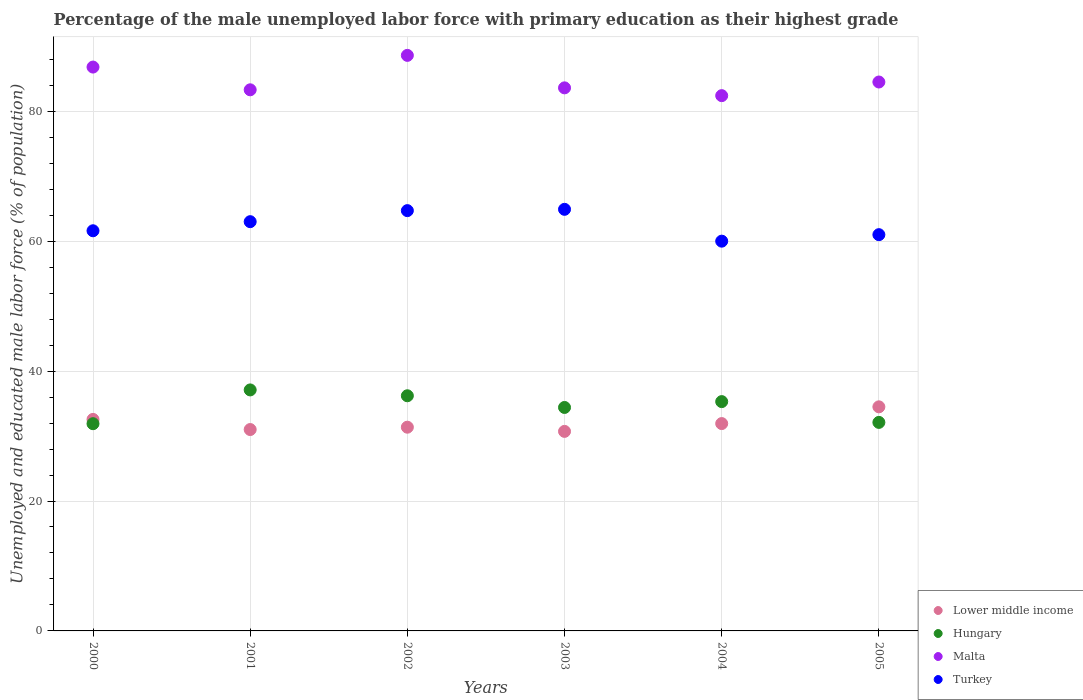What is the percentage of the unemployed male labor force with primary education in Turkey in 2003?
Your response must be concise. 64.9. Across all years, what is the maximum percentage of the unemployed male labor force with primary education in Turkey?
Provide a succinct answer. 64.9. Across all years, what is the minimum percentage of the unemployed male labor force with primary education in Lower middle income?
Keep it short and to the point. 30.72. In which year was the percentage of the unemployed male labor force with primary education in Turkey minimum?
Ensure brevity in your answer.  2004. What is the total percentage of the unemployed male labor force with primary education in Turkey in the graph?
Your answer should be compact. 375.2. What is the difference between the percentage of the unemployed male labor force with primary education in Lower middle income in 2000 and that in 2003?
Keep it short and to the point. 1.84. What is the difference between the percentage of the unemployed male labor force with primary education in Turkey in 2004 and the percentage of the unemployed male labor force with primary education in Malta in 2003?
Offer a very short reply. -23.6. What is the average percentage of the unemployed male labor force with primary education in Malta per year?
Your answer should be compact. 84.87. In the year 2002, what is the difference between the percentage of the unemployed male labor force with primary education in Lower middle income and percentage of the unemployed male labor force with primary education in Malta?
Your answer should be compact. -57.24. What is the ratio of the percentage of the unemployed male labor force with primary education in Turkey in 2000 to that in 2002?
Your answer should be very brief. 0.95. Is the percentage of the unemployed male labor force with primary education in Lower middle income in 2002 less than that in 2004?
Your response must be concise. Yes. Is the difference between the percentage of the unemployed male labor force with primary education in Lower middle income in 2000 and 2004 greater than the difference between the percentage of the unemployed male labor force with primary education in Malta in 2000 and 2004?
Keep it short and to the point. No. What is the difference between the highest and the second highest percentage of the unemployed male labor force with primary education in Turkey?
Give a very brief answer. 0.2. What is the difference between the highest and the lowest percentage of the unemployed male labor force with primary education in Malta?
Your answer should be compact. 6.2. In how many years, is the percentage of the unemployed male labor force with primary education in Turkey greater than the average percentage of the unemployed male labor force with primary education in Turkey taken over all years?
Keep it short and to the point. 3. Is the sum of the percentage of the unemployed male labor force with primary education in Turkey in 2002 and 2004 greater than the maximum percentage of the unemployed male labor force with primary education in Malta across all years?
Ensure brevity in your answer.  Yes. Does the percentage of the unemployed male labor force with primary education in Lower middle income monotonically increase over the years?
Offer a terse response. No. How many years are there in the graph?
Make the answer very short. 6. Are the values on the major ticks of Y-axis written in scientific E-notation?
Offer a very short reply. No. Does the graph contain any zero values?
Your response must be concise. No. Does the graph contain grids?
Your answer should be very brief. Yes. How many legend labels are there?
Ensure brevity in your answer.  4. How are the legend labels stacked?
Your response must be concise. Vertical. What is the title of the graph?
Ensure brevity in your answer.  Percentage of the male unemployed labor force with primary education as their highest grade. What is the label or title of the X-axis?
Your answer should be compact. Years. What is the label or title of the Y-axis?
Your response must be concise. Unemployed and educated male labor force (% of population). What is the Unemployed and educated male labor force (% of population) in Lower middle income in 2000?
Provide a succinct answer. 32.56. What is the Unemployed and educated male labor force (% of population) in Hungary in 2000?
Your answer should be compact. 31.9. What is the Unemployed and educated male labor force (% of population) in Malta in 2000?
Your answer should be compact. 86.8. What is the Unemployed and educated male labor force (% of population) of Turkey in 2000?
Offer a very short reply. 61.6. What is the Unemployed and educated male labor force (% of population) of Lower middle income in 2001?
Your answer should be very brief. 31. What is the Unemployed and educated male labor force (% of population) of Hungary in 2001?
Give a very brief answer. 37.1. What is the Unemployed and educated male labor force (% of population) of Malta in 2001?
Give a very brief answer. 83.3. What is the Unemployed and educated male labor force (% of population) in Turkey in 2001?
Give a very brief answer. 63. What is the Unemployed and educated male labor force (% of population) of Lower middle income in 2002?
Give a very brief answer. 31.36. What is the Unemployed and educated male labor force (% of population) of Hungary in 2002?
Make the answer very short. 36.2. What is the Unemployed and educated male labor force (% of population) of Malta in 2002?
Make the answer very short. 88.6. What is the Unemployed and educated male labor force (% of population) of Turkey in 2002?
Your answer should be very brief. 64.7. What is the Unemployed and educated male labor force (% of population) of Lower middle income in 2003?
Keep it short and to the point. 30.72. What is the Unemployed and educated male labor force (% of population) in Hungary in 2003?
Give a very brief answer. 34.4. What is the Unemployed and educated male labor force (% of population) of Malta in 2003?
Your answer should be compact. 83.6. What is the Unemployed and educated male labor force (% of population) of Turkey in 2003?
Provide a short and direct response. 64.9. What is the Unemployed and educated male labor force (% of population) of Lower middle income in 2004?
Provide a short and direct response. 31.92. What is the Unemployed and educated male labor force (% of population) of Hungary in 2004?
Provide a short and direct response. 35.3. What is the Unemployed and educated male labor force (% of population) of Malta in 2004?
Give a very brief answer. 82.4. What is the Unemployed and educated male labor force (% of population) in Turkey in 2004?
Your answer should be very brief. 60. What is the Unemployed and educated male labor force (% of population) of Lower middle income in 2005?
Offer a terse response. 34.5. What is the Unemployed and educated male labor force (% of population) in Hungary in 2005?
Give a very brief answer. 32.1. What is the Unemployed and educated male labor force (% of population) of Malta in 2005?
Provide a short and direct response. 84.5. Across all years, what is the maximum Unemployed and educated male labor force (% of population) in Lower middle income?
Keep it short and to the point. 34.5. Across all years, what is the maximum Unemployed and educated male labor force (% of population) in Hungary?
Make the answer very short. 37.1. Across all years, what is the maximum Unemployed and educated male labor force (% of population) in Malta?
Your response must be concise. 88.6. Across all years, what is the maximum Unemployed and educated male labor force (% of population) of Turkey?
Your answer should be compact. 64.9. Across all years, what is the minimum Unemployed and educated male labor force (% of population) of Lower middle income?
Your answer should be very brief. 30.72. Across all years, what is the minimum Unemployed and educated male labor force (% of population) in Hungary?
Provide a short and direct response. 31.9. Across all years, what is the minimum Unemployed and educated male labor force (% of population) of Malta?
Your answer should be very brief. 82.4. Across all years, what is the minimum Unemployed and educated male labor force (% of population) of Turkey?
Provide a short and direct response. 60. What is the total Unemployed and educated male labor force (% of population) of Lower middle income in the graph?
Your response must be concise. 192.05. What is the total Unemployed and educated male labor force (% of population) in Hungary in the graph?
Your answer should be very brief. 207. What is the total Unemployed and educated male labor force (% of population) of Malta in the graph?
Your answer should be compact. 509.2. What is the total Unemployed and educated male labor force (% of population) in Turkey in the graph?
Offer a very short reply. 375.2. What is the difference between the Unemployed and educated male labor force (% of population) in Lower middle income in 2000 and that in 2001?
Provide a succinct answer. 1.56. What is the difference between the Unemployed and educated male labor force (% of population) of Malta in 2000 and that in 2001?
Keep it short and to the point. 3.5. What is the difference between the Unemployed and educated male labor force (% of population) in Turkey in 2000 and that in 2001?
Keep it short and to the point. -1.4. What is the difference between the Unemployed and educated male labor force (% of population) in Lower middle income in 2000 and that in 2002?
Your response must be concise. 1.2. What is the difference between the Unemployed and educated male labor force (% of population) of Malta in 2000 and that in 2002?
Provide a succinct answer. -1.8. What is the difference between the Unemployed and educated male labor force (% of population) of Lower middle income in 2000 and that in 2003?
Give a very brief answer. 1.84. What is the difference between the Unemployed and educated male labor force (% of population) in Turkey in 2000 and that in 2003?
Offer a very short reply. -3.3. What is the difference between the Unemployed and educated male labor force (% of population) in Lower middle income in 2000 and that in 2004?
Keep it short and to the point. 0.64. What is the difference between the Unemployed and educated male labor force (% of population) in Hungary in 2000 and that in 2004?
Offer a terse response. -3.4. What is the difference between the Unemployed and educated male labor force (% of population) in Lower middle income in 2000 and that in 2005?
Offer a very short reply. -1.94. What is the difference between the Unemployed and educated male labor force (% of population) in Malta in 2000 and that in 2005?
Provide a short and direct response. 2.3. What is the difference between the Unemployed and educated male labor force (% of population) of Lower middle income in 2001 and that in 2002?
Your answer should be very brief. -0.36. What is the difference between the Unemployed and educated male labor force (% of population) of Malta in 2001 and that in 2002?
Keep it short and to the point. -5.3. What is the difference between the Unemployed and educated male labor force (% of population) of Lower middle income in 2001 and that in 2003?
Provide a short and direct response. 0.28. What is the difference between the Unemployed and educated male labor force (% of population) of Lower middle income in 2001 and that in 2004?
Ensure brevity in your answer.  -0.92. What is the difference between the Unemployed and educated male labor force (% of population) of Hungary in 2001 and that in 2004?
Your answer should be very brief. 1.8. What is the difference between the Unemployed and educated male labor force (% of population) of Malta in 2001 and that in 2004?
Keep it short and to the point. 0.9. What is the difference between the Unemployed and educated male labor force (% of population) of Lower middle income in 2001 and that in 2005?
Provide a succinct answer. -3.49. What is the difference between the Unemployed and educated male labor force (% of population) of Hungary in 2001 and that in 2005?
Provide a succinct answer. 5. What is the difference between the Unemployed and educated male labor force (% of population) of Lower middle income in 2002 and that in 2003?
Give a very brief answer. 0.65. What is the difference between the Unemployed and educated male labor force (% of population) of Lower middle income in 2002 and that in 2004?
Make the answer very short. -0.56. What is the difference between the Unemployed and educated male labor force (% of population) of Malta in 2002 and that in 2004?
Offer a terse response. 6.2. What is the difference between the Unemployed and educated male labor force (% of population) in Lower middle income in 2002 and that in 2005?
Your response must be concise. -3.13. What is the difference between the Unemployed and educated male labor force (% of population) of Malta in 2002 and that in 2005?
Your answer should be very brief. 4.1. What is the difference between the Unemployed and educated male labor force (% of population) of Turkey in 2002 and that in 2005?
Provide a short and direct response. 3.7. What is the difference between the Unemployed and educated male labor force (% of population) of Lower middle income in 2003 and that in 2004?
Your answer should be compact. -1.2. What is the difference between the Unemployed and educated male labor force (% of population) of Hungary in 2003 and that in 2004?
Your answer should be compact. -0.9. What is the difference between the Unemployed and educated male labor force (% of population) of Turkey in 2003 and that in 2004?
Offer a terse response. 4.9. What is the difference between the Unemployed and educated male labor force (% of population) in Lower middle income in 2003 and that in 2005?
Ensure brevity in your answer.  -3.78. What is the difference between the Unemployed and educated male labor force (% of population) in Turkey in 2003 and that in 2005?
Make the answer very short. 3.9. What is the difference between the Unemployed and educated male labor force (% of population) of Lower middle income in 2004 and that in 2005?
Provide a succinct answer. -2.58. What is the difference between the Unemployed and educated male labor force (% of population) of Malta in 2004 and that in 2005?
Give a very brief answer. -2.1. What is the difference between the Unemployed and educated male labor force (% of population) of Lower middle income in 2000 and the Unemployed and educated male labor force (% of population) of Hungary in 2001?
Keep it short and to the point. -4.54. What is the difference between the Unemployed and educated male labor force (% of population) in Lower middle income in 2000 and the Unemployed and educated male labor force (% of population) in Malta in 2001?
Give a very brief answer. -50.74. What is the difference between the Unemployed and educated male labor force (% of population) in Lower middle income in 2000 and the Unemployed and educated male labor force (% of population) in Turkey in 2001?
Make the answer very short. -30.44. What is the difference between the Unemployed and educated male labor force (% of population) in Hungary in 2000 and the Unemployed and educated male labor force (% of population) in Malta in 2001?
Your answer should be compact. -51.4. What is the difference between the Unemployed and educated male labor force (% of population) in Hungary in 2000 and the Unemployed and educated male labor force (% of population) in Turkey in 2001?
Your answer should be compact. -31.1. What is the difference between the Unemployed and educated male labor force (% of population) in Malta in 2000 and the Unemployed and educated male labor force (% of population) in Turkey in 2001?
Your answer should be very brief. 23.8. What is the difference between the Unemployed and educated male labor force (% of population) in Lower middle income in 2000 and the Unemployed and educated male labor force (% of population) in Hungary in 2002?
Give a very brief answer. -3.64. What is the difference between the Unemployed and educated male labor force (% of population) in Lower middle income in 2000 and the Unemployed and educated male labor force (% of population) in Malta in 2002?
Ensure brevity in your answer.  -56.04. What is the difference between the Unemployed and educated male labor force (% of population) in Lower middle income in 2000 and the Unemployed and educated male labor force (% of population) in Turkey in 2002?
Give a very brief answer. -32.14. What is the difference between the Unemployed and educated male labor force (% of population) of Hungary in 2000 and the Unemployed and educated male labor force (% of population) of Malta in 2002?
Keep it short and to the point. -56.7. What is the difference between the Unemployed and educated male labor force (% of population) in Hungary in 2000 and the Unemployed and educated male labor force (% of population) in Turkey in 2002?
Provide a short and direct response. -32.8. What is the difference between the Unemployed and educated male labor force (% of population) of Malta in 2000 and the Unemployed and educated male labor force (% of population) of Turkey in 2002?
Offer a very short reply. 22.1. What is the difference between the Unemployed and educated male labor force (% of population) of Lower middle income in 2000 and the Unemployed and educated male labor force (% of population) of Hungary in 2003?
Ensure brevity in your answer.  -1.84. What is the difference between the Unemployed and educated male labor force (% of population) in Lower middle income in 2000 and the Unemployed and educated male labor force (% of population) in Malta in 2003?
Your answer should be very brief. -51.04. What is the difference between the Unemployed and educated male labor force (% of population) of Lower middle income in 2000 and the Unemployed and educated male labor force (% of population) of Turkey in 2003?
Ensure brevity in your answer.  -32.34. What is the difference between the Unemployed and educated male labor force (% of population) of Hungary in 2000 and the Unemployed and educated male labor force (% of population) of Malta in 2003?
Keep it short and to the point. -51.7. What is the difference between the Unemployed and educated male labor force (% of population) of Hungary in 2000 and the Unemployed and educated male labor force (% of population) of Turkey in 2003?
Offer a very short reply. -33. What is the difference between the Unemployed and educated male labor force (% of population) in Malta in 2000 and the Unemployed and educated male labor force (% of population) in Turkey in 2003?
Provide a succinct answer. 21.9. What is the difference between the Unemployed and educated male labor force (% of population) of Lower middle income in 2000 and the Unemployed and educated male labor force (% of population) of Hungary in 2004?
Ensure brevity in your answer.  -2.74. What is the difference between the Unemployed and educated male labor force (% of population) of Lower middle income in 2000 and the Unemployed and educated male labor force (% of population) of Malta in 2004?
Provide a short and direct response. -49.84. What is the difference between the Unemployed and educated male labor force (% of population) in Lower middle income in 2000 and the Unemployed and educated male labor force (% of population) in Turkey in 2004?
Keep it short and to the point. -27.44. What is the difference between the Unemployed and educated male labor force (% of population) of Hungary in 2000 and the Unemployed and educated male labor force (% of population) of Malta in 2004?
Offer a terse response. -50.5. What is the difference between the Unemployed and educated male labor force (% of population) in Hungary in 2000 and the Unemployed and educated male labor force (% of population) in Turkey in 2004?
Your answer should be compact. -28.1. What is the difference between the Unemployed and educated male labor force (% of population) in Malta in 2000 and the Unemployed and educated male labor force (% of population) in Turkey in 2004?
Offer a terse response. 26.8. What is the difference between the Unemployed and educated male labor force (% of population) of Lower middle income in 2000 and the Unemployed and educated male labor force (% of population) of Hungary in 2005?
Your response must be concise. 0.46. What is the difference between the Unemployed and educated male labor force (% of population) in Lower middle income in 2000 and the Unemployed and educated male labor force (% of population) in Malta in 2005?
Make the answer very short. -51.94. What is the difference between the Unemployed and educated male labor force (% of population) in Lower middle income in 2000 and the Unemployed and educated male labor force (% of population) in Turkey in 2005?
Your response must be concise. -28.44. What is the difference between the Unemployed and educated male labor force (% of population) in Hungary in 2000 and the Unemployed and educated male labor force (% of population) in Malta in 2005?
Provide a succinct answer. -52.6. What is the difference between the Unemployed and educated male labor force (% of population) in Hungary in 2000 and the Unemployed and educated male labor force (% of population) in Turkey in 2005?
Give a very brief answer. -29.1. What is the difference between the Unemployed and educated male labor force (% of population) in Malta in 2000 and the Unemployed and educated male labor force (% of population) in Turkey in 2005?
Offer a very short reply. 25.8. What is the difference between the Unemployed and educated male labor force (% of population) in Lower middle income in 2001 and the Unemployed and educated male labor force (% of population) in Hungary in 2002?
Your answer should be compact. -5.2. What is the difference between the Unemployed and educated male labor force (% of population) of Lower middle income in 2001 and the Unemployed and educated male labor force (% of population) of Malta in 2002?
Keep it short and to the point. -57.6. What is the difference between the Unemployed and educated male labor force (% of population) of Lower middle income in 2001 and the Unemployed and educated male labor force (% of population) of Turkey in 2002?
Offer a very short reply. -33.7. What is the difference between the Unemployed and educated male labor force (% of population) of Hungary in 2001 and the Unemployed and educated male labor force (% of population) of Malta in 2002?
Offer a terse response. -51.5. What is the difference between the Unemployed and educated male labor force (% of population) of Hungary in 2001 and the Unemployed and educated male labor force (% of population) of Turkey in 2002?
Your answer should be compact. -27.6. What is the difference between the Unemployed and educated male labor force (% of population) in Lower middle income in 2001 and the Unemployed and educated male labor force (% of population) in Hungary in 2003?
Make the answer very short. -3.4. What is the difference between the Unemployed and educated male labor force (% of population) of Lower middle income in 2001 and the Unemployed and educated male labor force (% of population) of Malta in 2003?
Give a very brief answer. -52.6. What is the difference between the Unemployed and educated male labor force (% of population) of Lower middle income in 2001 and the Unemployed and educated male labor force (% of population) of Turkey in 2003?
Keep it short and to the point. -33.9. What is the difference between the Unemployed and educated male labor force (% of population) in Hungary in 2001 and the Unemployed and educated male labor force (% of population) in Malta in 2003?
Provide a short and direct response. -46.5. What is the difference between the Unemployed and educated male labor force (% of population) of Hungary in 2001 and the Unemployed and educated male labor force (% of population) of Turkey in 2003?
Your answer should be very brief. -27.8. What is the difference between the Unemployed and educated male labor force (% of population) in Lower middle income in 2001 and the Unemployed and educated male labor force (% of population) in Hungary in 2004?
Make the answer very short. -4.3. What is the difference between the Unemployed and educated male labor force (% of population) in Lower middle income in 2001 and the Unemployed and educated male labor force (% of population) in Malta in 2004?
Make the answer very short. -51.4. What is the difference between the Unemployed and educated male labor force (% of population) in Lower middle income in 2001 and the Unemployed and educated male labor force (% of population) in Turkey in 2004?
Offer a terse response. -29. What is the difference between the Unemployed and educated male labor force (% of population) of Hungary in 2001 and the Unemployed and educated male labor force (% of population) of Malta in 2004?
Provide a succinct answer. -45.3. What is the difference between the Unemployed and educated male labor force (% of population) in Hungary in 2001 and the Unemployed and educated male labor force (% of population) in Turkey in 2004?
Your answer should be compact. -22.9. What is the difference between the Unemployed and educated male labor force (% of population) of Malta in 2001 and the Unemployed and educated male labor force (% of population) of Turkey in 2004?
Give a very brief answer. 23.3. What is the difference between the Unemployed and educated male labor force (% of population) in Lower middle income in 2001 and the Unemployed and educated male labor force (% of population) in Hungary in 2005?
Your answer should be very brief. -1.1. What is the difference between the Unemployed and educated male labor force (% of population) of Lower middle income in 2001 and the Unemployed and educated male labor force (% of population) of Malta in 2005?
Provide a short and direct response. -53.5. What is the difference between the Unemployed and educated male labor force (% of population) in Lower middle income in 2001 and the Unemployed and educated male labor force (% of population) in Turkey in 2005?
Make the answer very short. -30. What is the difference between the Unemployed and educated male labor force (% of population) in Hungary in 2001 and the Unemployed and educated male labor force (% of population) in Malta in 2005?
Your answer should be compact. -47.4. What is the difference between the Unemployed and educated male labor force (% of population) of Hungary in 2001 and the Unemployed and educated male labor force (% of population) of Turkey in 2005?
Offer a very short reply. -23.9. What is the difference between the Unemployed and educated male labor force (% of population) in Malta in 2001 and the Unemployed and educated male labor force (% of population) in Turkey in 2005?
Provide a short and direct response. 22.3. What is the difference between the Unemployed and educated male labor force (% of population) of Lower middle income in 2002 and the Unemployed and educated male labor force (% of population) of Hungary in 2003?
Provide a succinct answer. -3.04. What is the difference between the Unemployed and educated male labor force (% of population) in Lower middle income in 2002 and the Unemployed and educated male labor force (% of population) in Malta in 2003?
Make the answer very short. -52.24. What is the difference between the Unemployed and educated male labor force (% of population) in Lower middle income in 2002 and the Unemployed and educated male labor force (% of population) in Turkey in 2003?
Offer a terse response. -33.54. What is the difference between the Unemployed and educated male labor force (% of population) of Hungary in 2002 and the Unemployed and educated male labor force (% of population) of Malta in 2003?
Your response must be concise. -47.4. What is the difference between the Unemployed and educated male labor force (% of population) in Hungary in 2002 and the Unemployed and educated male labor force (% of population) in Turkey in 2003?
Provide a succinct answer. -28.7. What is the difference between the Unemployed and educated male labor force (% of population) of Malta in 2002 and the Unemployed and educated male labor force (% of population) of Turkey in 2003?
Give a very brief answer. 23.7. What is the difference between the Unemployed and educated male labor force (% of population) of Lower middle income in 2002 and the Unemployed and educated male labor force (% of population) of Hungary in 2004?
Provide a succinct answer. -3.94. What is the difference between the Unemployed and educated male labor force (% of population) of Lower middle income in 2002 and the Unemployed and educated male labor force (% of population) of Malta in 2004?
Keep it short and to the point. -51.04. What is the difference between the Unemployed and educated male labor force (% of population) of Lower middle income in 2002 and the Unemployed and educated male labor force (% of population) of Turkey in 2004?
Make the answer very short. -28.64. What is the difference between the Unemployed and educated male labor force (% of population) in Hungary in 2002 and the Unemployed and educated male labor force (% of population) in Malta in 2004?
Offer a terse response. -46.2. What is the difference between the Unemployed and educated male labor force (% of population) of Hungary in 2002 and the Unemployed and educated male labor force (% of population) of Turkey in 2004?
Your answer should be compact. -23.8. What is the difference between the Unemployed and educated male labor force (% of population) of Malta in 2002 and the Unemployed and educated male labor force (% of population) of Turkey in 2004?
Provide a short and direct response. 28.6. What is the difference between the Unemployed and educated male labor force (% of population) in Lower middle income in 2002 and the Unemployed and educated male labor force (% of population) in Hungary in 2005?
Keep it short and to the point. -0.74. What is the difference between the Unemployed and educated male labor force (% of population) in Lower middle income in 2002 and the Unemployed and educated male labor force (% of population) in Malta in 2005?
Give a very brief answer. -53.14. What is the difference between the Unemployed and educated male labor force (% of population) of Lower middle income in 2002 and the Unemployed and educated male labor force (% of population) of Turkey in 2005?
Your response must be concise. -29.64. What is the difference between the Unemployed and educated male labor force (% of population) in Hungary in 2002 and the Unemployed and educated male labor force (% of population) in Malta in 2005?
Your response must be concise. -48.3. What is the difference between the Unemployed and educated male labor force (% of population) in Hungary in 2002 and the Unemployed and educated male labor force (% of population) in Turkey in 2005?
Offer a very short reply. -24.8. What is the difference between the Unemployed and educated male labor force (% of population) of Malta in 2002 and the Unemployed and educated male labor force (% of population) of Turkey in 2005?
Provide a succinct answer. 27.6. What is the difference between the Unemployed and educated male labor force (% of population) in Lower middle income in 2003 and the Unemployed and educated male labor force (% of population) in Hungary in 2004?
Offer a terse response. -4.58. What is the difference between the Unemployed and educated male labor force (% of population) of Lower middle income in 2003 and the Unemployed and educated male labor force (% of population) of Malta in 2004?
Your answer should be very brief. -51.68. What is the difference between the Unemployed and educated male labor force (% of population) of Lower middle income in 2003 and the Unemployed and educated male labor force (% of population) of Turkey in 2004?
Offer a terse response. -29.28. What is the difference between the Unemployed and educated male labor force (% of population) of Hungary in 2003 and the Unemployed and educated male labor force (% of population) of Malta in 2004?
Offer a very short reply. -48. What is the difference between the Unemployed and educated male labor force (% of population) in Hungary in 2003 and the Unemployed and educated male labor force (% of population) in Turkey in 2004?
Make the answer very short. -25.6. What is the difference between the Unemployed and educated male labor force (% of population) of Malta in 2003 and the Unemployed and educated male labor force (% of population) of Turkey in 2004?
Your answer should be very brief. 23.6. What is the difference between the Unemployed and educated male labor force (% of population) in Lower middle income in 2003 and the Unemployed and educated male labor force (% of population) in Hungary in 2005?
Your answer should be very brief. -1.38. What is the difference between the Unemployed and educated male labor force (% of population) of Lower middle income in 2003 and the Unemployed and educated male labor force (% of population) of Malta in 2005?
Offer a terse response. -53.78. What is the difference between the Unemployed and educated male labor force (% of population) of Lower middle income in 2003 and the Unemployed and educated male labor force (% of population) of Turkey in 2005?
Provide a succinct answer. -30.28. What is the difference between the Unemployed and educated male labor force (% of population) in Hungary in 2003 and the Unemployed and educated male labor force (% of population) in Malta in 2005?
Offer a terse response. -50.1. What is the difference between the Unemployed and educated male labor force (% of population) of Hungary in 2003 and the Unemployed and educated male labor force (% of population) of Turkey in 2005?
Provide a succinct answer. -26.6. What is the difference between the Unemployed and educated male labor force (% of population) of Malta in 2003 and the Unemployed and educated male labor force (% of population) of Turkey in 2005?
Your response must be concise. 22.6. What is the difference between the Unemployed and educated male labor force (% of population) of Lower middle income in 2004 and the Unemployed and educated male labor force (% of population) of Hungary in 2005?
Make the answer very short. -0.18. What is the difference between the Unemployed and educated male labor force (% of population) of Lower middle income in 2004 and the Unemployed and educated male labor force (% of population) of Malta in 2005?
Make the answer very short. -52.58. What is the difference between the Unemployed and educated male labor force (% of population) in Lower middle income in 2004 and the Unemployed and educated male labor force (% of population) in Turkey in 2005?
Your response must be concise. -29.08. What is the difference between the Unemployed and educated male labor force (% of population) in Hungary in 2004 and the Unemployed and educated male labor force (% of population) in Malta in 2005?
Give a very brief answer. -49.2. What is the difference between the Unemployed and educated male labor force (% of population) in Hungary in 2004 and the Unemployed and educated male labor force (% of population) in Turkey in 2005?
Keep it short and to the point. -25.7. What is the difference between the Unemployed and educated male labor force (% of population) of Malta in 2004 and the Unemployed and educated male labor force (% of population) of Turkey in 2005?
Provide a succinct answer. 21.4. What is the average Unemployed and educated male labor force (% of population) in Lower middle income per year?
Give a very brief answer. 32.01. What is the average Unemployed and educated male labor force (% of population) in Hungary per year?
Your response must be concise. 34.5. What is the average Unemployed and educated male labor force (% of population) of Malta per year?
Keep it short and to the point. 84.87. What is the average Unemployed and educated male labor force (% of population) in Turkey per year?
Make the answer very short. 62.53. In the year 2000, what is the difference between the Unemployed and educated male labor force (% of population) of Lower middle income and Unemployed and educated male labor force (% of population) of Hungary?
Your response must be concise. 0.66. In the year 2000, what is the difference between the Unemployed and educated male labor force (% of population) of Lower middle income and Unemployed and educated male labor force (% of population) of Malta?
Your response must be concise. -54.24. In the year 2000, what is the difference between the Unemployed and educated male labor force (% of population) of Lower middle income and Unemployed and educated male labor force (% of population) of Turkey?
Give a very brief answer. -29.04. In the year 2000, what is the difference between the Unemployed and educated male labor force (% of population) in Hungary and Unemployed and educated male labor force (% of population) in Malta?
Your response must be concise. -54.9. In the year 2000, what is the difference between the Unemployed and educated male labor force (% of population) of Hungary and Unemployed and educated male labor force (% of population) of Turkey?
Offer a terse response. -29.7. In the year 2000, what is the difference between the Unemployed and educated male labor force (% of population) in Malta and Unemployed and educated male labor force (% of population) in Turkey?
Keep it short and to the point. 25.2. In the year 2001, what is the difference between the Unemployed and educated male labor force (% of population) of Lower middle income and Unemployed and educated male labor force (% of population) of Hungary?
Keep it short and to the point. -6.1. In the year 2001, what is the difference between the Unemployed and educated male labor force (% of population) in Lower middle income and Unemployed and educated male labor force (% of population) in Malta?
Ensure brevity in your answer.  -52.3. In the year 2001, what is the difference between the Unemployed and educated male labor force (% of population) of Lower middle income and Unemployed and educated male labor force (% of population) of Turkey?
Your answer should be compact. -32. In the year 2001, what is the difference between the Unemployed and educated male labor force (% of population) in Hungary and Unemployed and educated male labor force (% of population) in Malta?
Your answer should be compact. -46.2. In the year 2001, what is the difference between the Unemployed and educated male labor force (% of population) in Hungary and Unemployed and educated male labor force (% of population) in Turkey?
Provide a succinct answer. -25.9. In the year 2001, what is the difference between the Unemployed and educated male labor force (% of population) in Malta and Unemployed and educated male labor force (% of population) in Turkey?
Offer a terse response. 20.3. In the year 2002, what is the difference between the Unemployed and educated male labor force (% of population) of Lower middle income and Unemployed and educated male labor force (% of population) of Hungary?
Make the answer very short. -4.84. In the year 2002, what is the difference between the Unemployed and educated male labor force (% of population) in Lower middle income and Unemployed and educated male labor force (% of population) in Malta?
Your answer should be compact. -57.24. In the year 2002, what is the difference between the Unemployed and educated male labor force (% of population) in Lower middle income and Unemployed and educated male labor force (% of population) in Turkey?
Offer a very short reply. -33.34. In the year 2002, what is the difference between the Unemployed and educated male labor force (% of population) in Hungary and Unemployed and educated male labor force (% of population) in Malta?
Give a very brief answer. -52.4. In the year 2002, what is the difference between the Unemployed and educated male labor force (% of population) of Hungary and Unemployed and educated male labor force (% of population) of Turkey?
Make the answer very short. -28.5. In the year 2002, what is the difference between the Unemployed and educated male labor force (% of population) of Malta and Unemployed and educated male labor force (% of population) of Turkey?
Provide a succinct answer. 23.9. In the year 2003, what is the difference between the Unemployed and educated male labor force (% of population) in Lower middle income and Unemployed and educated male labor force (% of population) in Hungary?
Give a very brief answer. -3.68. In the year 2003, what is the difference between the Unemployed and educated male labor force (% of population) of Lower middle income and Unemployed and educated male labor force (% of population) of Malta?
Make the answer very short. -52.88. In the year 2003, what is the difference between the Unemployed and educated male labor force (% of population) of Lower middle income and Unemployed and educated male labor force (% of population) of Turkey?
Ensure brevity in your answer.  -34.18. In the year 2003, what is the difference between the Unemployed and educated male labor force (% of population) of Hungary and Unemployed and educated male labor force (% of population) of Malta?
Ensure brevity in your answer.  -49.2. In the year 2003, what is the difference between the Unemployed and educated male labor force (% of population) in Hungary and Unemployed and educated male labor force (% of population) in Turkey?
Keep it short and to the point. -30.5. In the year 2004, what is the difference between the Unemployed and educated male labor force (% of population) in Lower middle income and Unemployed and educated male labor force (% of population) in Hungary?
Your answer should be compact. -3.38. In the year 2004, what is the difference between the Unemployed and educated male labor force (% of population) in Lower middle income and Unemployed and educated male labor force (% of population) in Malta?
Provide a short and direct response. -50.48. In the year 2004, what is the difference between the Unemployed and educated male labor force (% of population) in Lower middle income and Unemployed and educated male labor force (% of population) in Turkey?
Make the answer very short. -28.08. In the year 2004, what is the difference between the Unemployed and educated male labor force (% of population) in Hungary and Unemployed and educated male labor force (% of population) in Malta?
Provide a short and direct response. -47.1. In the year 2004, what is the difference between the Unemployed and educated male labor force (% of population) in Hungary and Unemployed and educated male labor force (% of population) in Turkey?
Offer a very short reply. -24.7. In the year 2004, what is the difference between the Unemployed and educated male labor force (% of population) in Malta and Unemployed and educated male labor force (% of population) in Turkey?
Make the answer very short. 22.4. In the year 2005, what is the difference between the Unemployed and educated male labor force (% of population) in Lower middle income and Unemployed and educated male labor force (% of population) in Hungary?
Give a very brief answer. 2.4. In the year 2005, what is the difference between the Unemployed and educated male labor force (% of population) of Lower middle income and Unemployed and educated male labor force (% of population) of Malta?
Your response must be concise. -50. In the year 2005, what is the difference between the Unemployed and educated male labor force (% of population) in Lower middle income and Unemployed and educated male labor force (% of population) in Turkey?
Your response must be concise. -26.5. In the year 2005, what is the difference between the Unemployed and educated male labor force (% of population) of Hungary and Unemployed and educated male labor force (% of population) of Malta?
Your response must be concise. -52.4. In the year 2005, what is the difference between the Unemployed and educated male labor force (% of population) in Hungary and Unemployed and educated male labor force (% of population) in Turkey?
Keep it short and to the point. -28.9. What is the ratio of the Unemployed and educated male labor force (% of population) in Lower middle income in 2000 to that in 2001?
Make the answer very short. 1.05. What is the ratio of the Unemployed and educated male labor force (% of population) of Hungary in 2000 to that in 2001?
Provide a succinct answer. 0.86. What is the ratio of the Unemployed and educated male labor force (% of population) of Malta in 2000 to that in 2001?
Provide a short and direct response. 1.04. What is the ratio of the Unemployed and educated male labor force (% of population) of Turkey in 2000 to that in 2001?
Keep it short and to the point. 0.98. What is the ratio of the Unemployed and educated male labor force (% of population) of Lower middle income in 2000 to that in 2002?
Give a very brief answer. 1.04. What is the ratio of the Unemployed and educated male labor force (% of population) in Hungary in 2000 to that in 2002?
Ensure brevity in your answer.  0.88. What is the ratio of the Unemployed and educated male labor force (% of population) in Malta in 2000 to that in 2002?
Offer a very short reply. 0.98. What is the ratio of the Unemployed and educated male labor force (% of population) in Turkey in 2000 to that in 2002?
Your answer should be very brief. 0.95. What is the ratio of the Unemployed and educated male labor force (% of population) of Lower middle income in 2000 to that in 2003?
Provide a succinct answer. 1.06. What is the ratio of the Unemployed and educated male labor force (% of population) in Hungary in 2000 to that in 2003?
Make the answer very short. 0.93. What is the ratio of the Unemployed and educated male labor force (% of population) of Malta in 2000 to that in 2003?
Offer a very short reply. 1.04. What is the ratio of the Unemployed and educated male labor force (% of population) in Turkey in 2000 to that in 2003?
Your answer should be very brief. 0.95. What is the ratio of the Unemployed and educated male labor force (% of population) of Lower middle income in 2000 to that in 2004?
Provide a short and direct response. 1.02. What is the ratio of the Unemployed and educated male labor force (% of population) of Hungary in 2000 to that in 2004?
Your response must be concise. 0.9. What is the ratio of the Unemployed and educated male labor force (% of population) in Malta in 2000 to that in 2004?
Offer a terse response. 1.05. What is the ratio of the Unemployed and educated male labor force (% of population) in Turkey in 2000 to that in 2004?
Make the answer very short. 1.03. What is the ratio of the Unemployed and educated male labor force (% of population) of Lower middle income in 2000 to that in 2005?
Give a very brief answer. 0.94. What is the ratio of the Unemployed and educated male labor force (% of population) of Malta in 2000 to that in 2005?
Offer a very short reply. 1.03. What is the ratio of the Unemployed and educated male labor force (% of population) in Turkey in 2000 to that in 2005?
Give a very brief answer. 1.01. What is the ratio of the Unemployed and educated male labor force (% of population) of Hungary in 2001 to that in 2002?
Give a very brief answer. 1.02. What is the ratio of the Unemployed and educated male labor force (% of population) of Malta in 2001 to that in 2002?
Offer a very short reply. 0.94. What is the ratio of the Unemployed and educated male labor force (% of population) of Turkey in 2001 to that in 2002?
Your answer should be very brief. 0.97. What is the ratio of the Unemployed and educated male labor force (% of population) of Lower middle income in 2001 to that in 2003?
Offer a very short reply. 1.01. What is the ratio of the Unemployed and educated male labor force (% of population) in Hungary in 2001 to that in 2003?
Keep it short and to the point. 1.08. What is the ratio of the Unemployed and educated male labor force (% of population) in Turkey in 2001 to that in 2003?
Provide a succinct answer. 0.97. What is the ratio of the Unemployed and educated male labor force (% of population) in Lower middle income in 2001 to that in 2004?
Your response must be concise. 0.97. What is the ratio of the Unemployed and educated male labor force (% of population) in Hungary in 2001 to that in 2004?
Keep it short and to the point. 1.05. What is the ratio of the Unemployed and educated male labor force (% of population) in Malta in 2001 to that in 2004?
Keep it short and to the point. 1.01. What is the ratio of the Unemployed and educated male labor force (% of population) in Lower middle income in 2001 to that in 2005?
Offer a very short reply. 0.9. What is the ratio of the Unemployed and educated male labor force (% of population) of Hungary in 2001 to that in 2005?
Offer a very short reply. 1.16. What is the ratio of the Unemployed and educated male labor force (% of population) in Malta in 2001 to that in 2005?
Ensure brevity in your answer.  0.99. What is the ratio of the Unemployed and educated male labor force (% of population) of Turkey in 2001 to that in 2005?
Your answer should be very brief. 1.03. What is the ratio of the Unemployed and educated male labor force (% of population) in Lower middle income in 2002 to that in 2003?
Your response must be concise. 1.02. What is the ratio of the Unemployed and educated male labor force (% of population) in Hungary in 2002 to that in 2003?
Offer a very short reply. 1.05. What is the ratio of the Unemployed and educated male labor force (% of population) in Malta in 2002 to that in 2003?
Your answer should be very brief. 1.06. What is the ratio of the Unemployed and educated male labor force (% of population) of Turkey in 2002 to that in 2003?
Give a very brief answer. 1. What is the ratio of the Unemployed and educated male labor force (% of population) of Lower middle income in 2002 to that in 2004?
Offer a very short reply. 0.98. What is the ratio of the Unemployed and educated male labor force (% of population) in Hungary in 2002 to that in 2004?
Give a very brief answer. 1.03. What is the ratio of the Unemployed and educated male labor force (% of population) of Malta in 2002 to that in 2004?
Your answer should be compact. 1.08. What is the ratio of the Unemployed and educated male labor force (% of population) of Turkey in 2002 to that in 2004?
Offer a terse response. 1.08. What is the ratio of the Unemployed and educated male labor force (% of population) in Lower middle income in 2002 to that in 2005?
Provide a succinct answer. 0.91. What is the ratio of the Unemployed and educated male labor force (% of population) in Hungary in 2002 to that in 2005?
Offer a terse response. 1.13. What is the ratio of the Unemployed and educated male labor force (% of population) in Malta in 2002 to that in 2005?
Keep it short and to the point. 1.05. What is the ratio of the Unemployed and educated male labor force (% of population) in Turkey in 2002 to that in 2005?
Provide a short and direct response. 1.06. What is the ratio of the Unemployed and educated male labor force (% of population) of Lower middle income in 2003 to that in 2004?
Make the answer very short. 0.96. What is the ratio of the Unemployed and educated male labor force (% of population) in Hungary in 2003 to that in 2004?
Your answer should be compact. 0.97. What is the ratio of the Unemployed and educated male labor force (% of population) in Malta in 2003 to that in 2004?
Offer a terse response. 1.01. What is the ratio of the Unemployed and educated male labor force (% of population) in Turkey in 2003 to that in 2004?
Your answer should be compact. 1.08. What is the ratio of the Unemployed and educated male labor force (% of population) of Lower middle income in 2003 to that in 2005?
Your answer should be compact. 0.89. What is the ratio of the Unemployed and educated male labor force (% of population) in Hungary in 2003 to that in 2005?
Your answer should be very brief. 1.07. What is the ratio of the Unemployed and educated male labor force (% of population) in Malta in 2003 to that in 2005?
Keep it short and to the point. 0.99. What is the ratio of the Unemployed and educated male labor force (% of population) in Turkey in 2003 to that in 2005?
Provide a succinct answer. 1.06. What is the ratio of the Unemployed and educated male labor force (% of population) of Lower middle income in 2004 to that in 2005?
Your answer should be compact. 0.93. What is the ratio of the Unemployed and educated male labor force (% of population) in Hungary in 2004 to that in 2005?
Provide a short and direct response. 1.1. What is the ratio of the Unemployed and educated male labor force (% of population) in Malta in 2004 to that in 2005?
Ensure brevity in your answer.  0.98. What is the ratio of the Unemployed and educated male labor force (% of population) in Turkey in 2004 to that in 2005?
Ensure brevity in your answer.  0.98. What is the difference between the highest and the second highest Unemployed and educated male labor force (% of population) in Lower middle income?
Give a very brief answer. 1.94. What is the difference between the highest and the lowest Unemployed and educated male labor force (% of population) in Lower middle income?
Your answer should be compact. 3.78. What is the difference between the highest and the lowest Unemployed and educated male labor force (% of population) in Hungary?
Make the answer very short. 5.2. What is the difference between the highest and the lowest Unemployed and educated male labor force (% of population) of Malta?
Your answer should be compact. 6.2. What is the difference between the highest and the lowest Unemployed and educated male labor force (% of population) in Turkey?
Offer a very short reply. 4.9. 